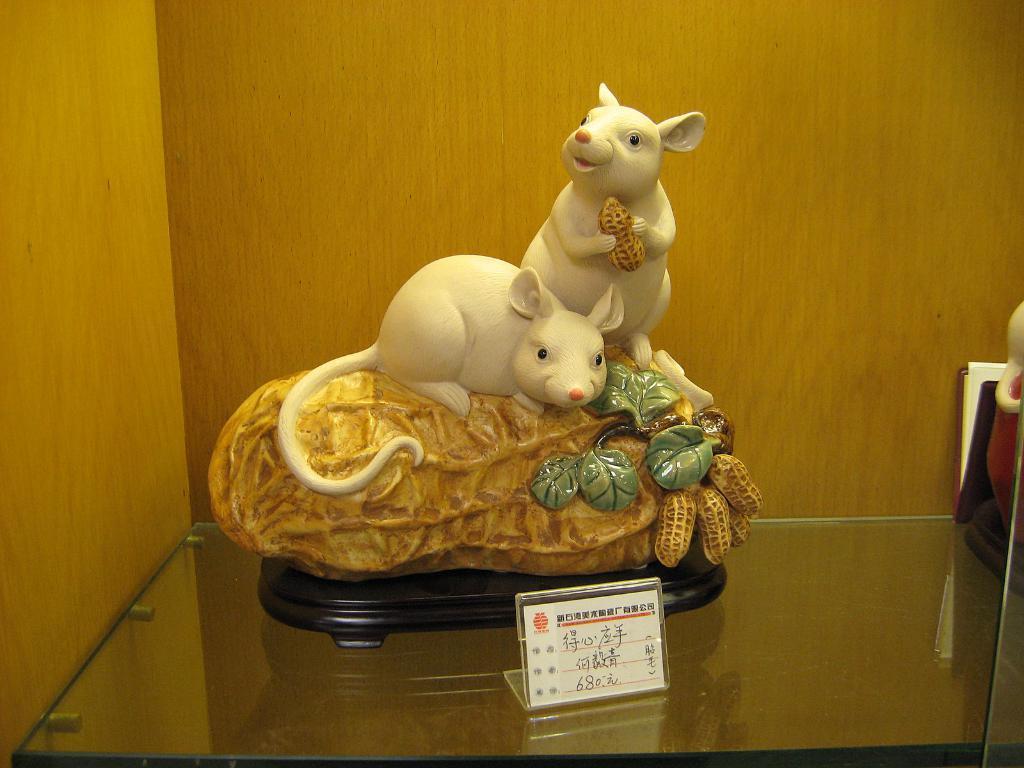Please provide a concise description of this image. In this picture we can see a statue, board and some objects and these all are on the glass shelf and in the background we can see a wooden wall. 